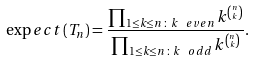Convert formula to latex. <formula><loc_0><loc_0><loc_500><loc_500>\exp e c t \left ( T _ { n } \right ) = \frac { \prod _ { 1 \leq k \leq n \, \colon \, k \, { \ e v e n } } k ^ { \binom { n } { k } } } { \prod _ { 1 \leq k \leq n \, \colon \, k \, { \ o d d } } k ^ { \binom { n } { k } } } .</formula> 